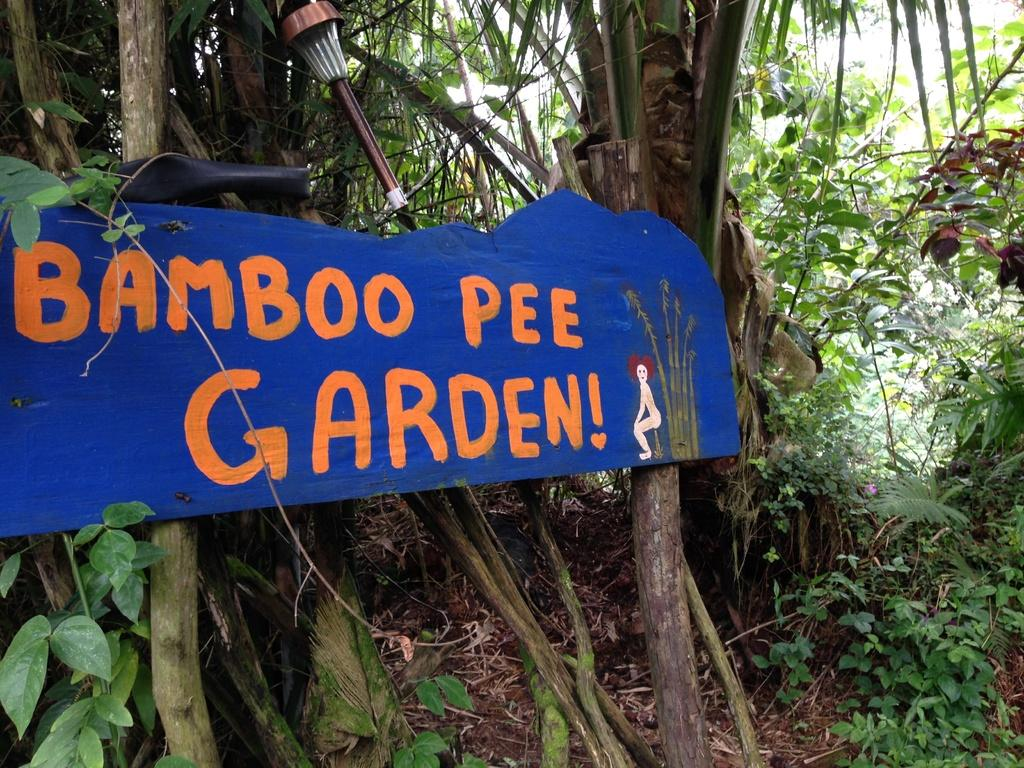What is the main object in the image? There is a board with text in the image. Where is the board located in the image? The board is in the front of the image. What can be seen in the background of the image? There are trees in the background of the image. What type of operation is being performed on the board in the image? There is no operation being performed on the board in the image; it is simply a board with text. What type of pleasure can be derived from the texture of the board in the image? There is no texture mentioned or visible on the board in the image, so it is not possible to derive any pleasure from it. 